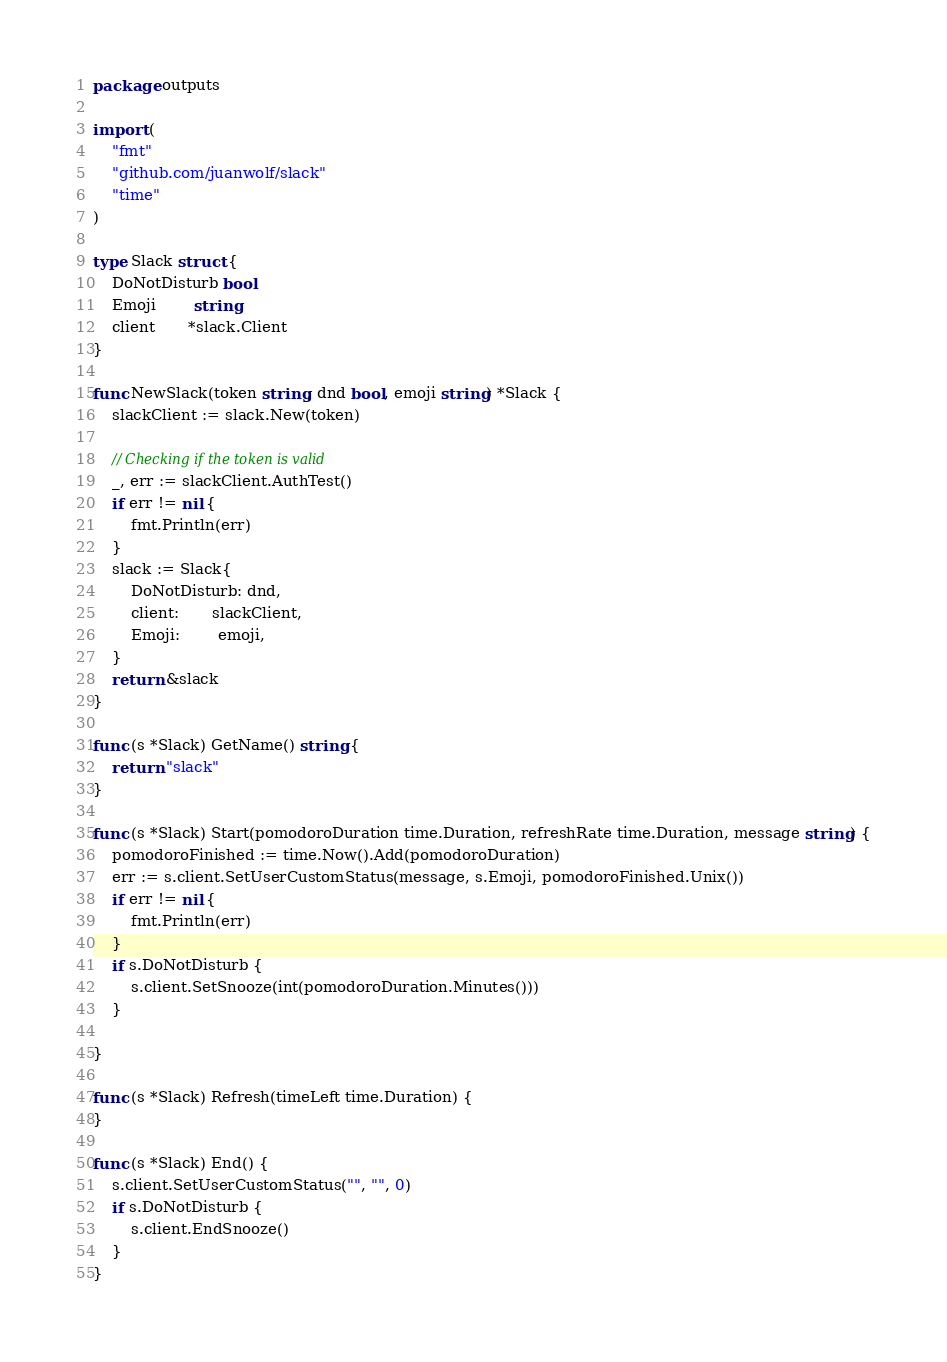Convert code to text. <code><loc_0><loc_0><loc_500><loc_500><_Go_>package outputs

import (
	"fmt"
	"github.com/juanwolf/slack"
	"time"
)

type Slack struct {
	DoNotDisturb bool
	Emoji        string
	client       *slack.Client
}

func NewSlack(token string, dnd bool, emoji string) *Slack {
	slackClient := slack.New(token)

	// Checking if the token is valid
	_, err := slackClient.AuthTest()
	if err != nil {
		fmt.Println(err)
	}
	slack := Slack{
		DoNotDisturb: dnd,
		client:       slackClient,
		Emoji:        emoji,
	}
	return &slack
}

func (s *Slack) GetName() string {
	return "slack"
}

func (s *Slack) Start(pomodoroDuration time.Duration, refreshRate time.Duration, message string) {
	pomodoroFinished := time.Now().Add(pomodoroDuration)
	err := s.client.SetUserCustomStatus(message, s.Emoji, pomodoroFinished.Unix())
	if err != nil {
		fmt.Println(err)
	}
	if s.DoNotDisturb {
		s.client.SetSnooze(int(pomodoroDuration.Minutes()))
	}

}

func (s *Slack) Refresh(timeLeft time.Duration) {
}

func (s *Slack) End() {
	s.client.SetUserCustomStatus("", "", 0)
	if s.DoNotDisturb {
		s.client.EndSnooze()
	}
}
</code> 